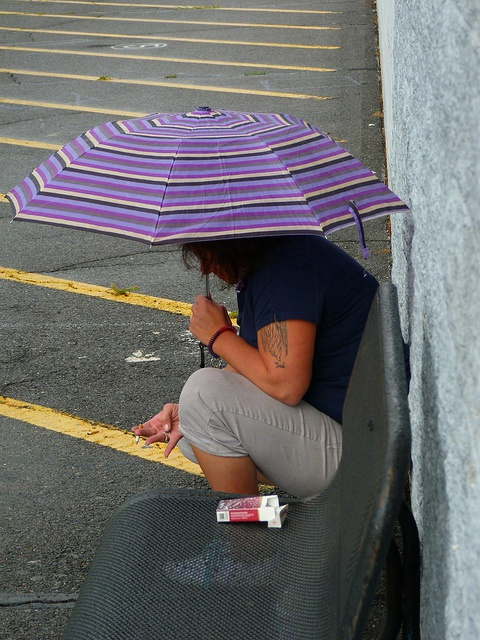Describe the objects in this image and their specific colors. I can see bench in gray, black, and purple tones, chair in gray, black, and purple tones, people in gray, black, darkgray, and brown tones, and umbrella in gray, purple, and violet tones in this image. 